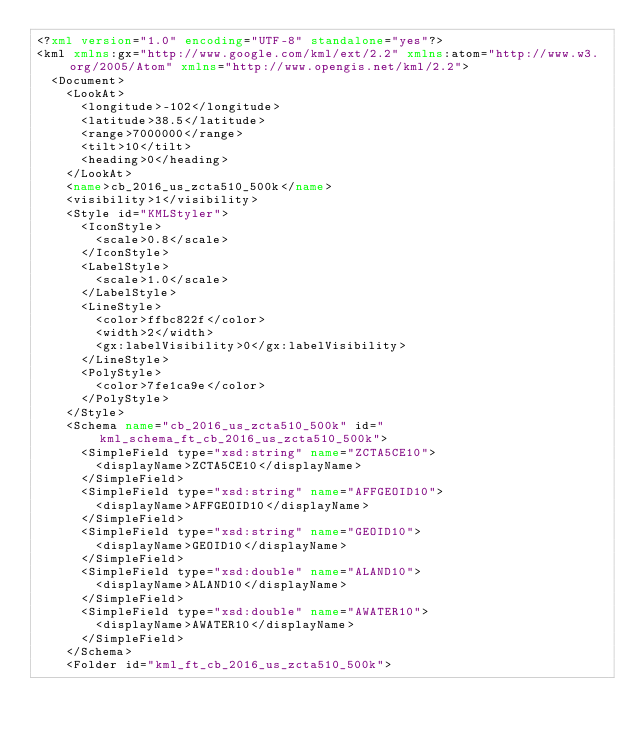<code> <loc_0><loc_0><loc_500><loc_500><_XML_><?xml version="1.0" encoding="UTF-8" standalone="yes"?>
<kml xmlns:gx="http://www.google.com/kml/ext/2.2" xmlns:atom="http://www.w3.org/2005/Atom" xmlns="http://www.opengis.net/kml/2.2">
  <Document>
    <LookAt>
      <longitude>-102</longitude>
      <latitude>38.5</latitude>
      <range>7000000</range>
      <tilt>10</tilt>
      <heading>0</heading>
    </LookAt>
    <name>cb_2016_us_zcta510_500k</name>
    <visibility>1</visibility>
    <Style id="KMLStyler">
      <IconStyle>
        <scale>0.8</scale>
      </IconStyle>
      <LabelStyle>
        <scale>1.0</scale>
      </LabelStyle>
      <LineStyle>
        <color>ffbc822f</color>
        <width>2</width>
        <gx:labelVisibility>0</gx:labelVisibility>
      </LineStyle>
      <PolyStyle>
        <color>7fe1ca9e</color>
      </PolyStyle>
    </Style>
    <Schema name="cb_2016_us_zcta510_500k" id="kml_schema_ft_cb_2016_us_zcta510_500k">
      <SimpleField type="xsd:string" name="ZCTA5CE10">
        <displayName>ZCTA5CE10</displayName>
      </SimpleField>
      <SimpleField type="xsd:string" name="AFFGEOID10">
        <displayName>AFFGEOID10</displayName>
      </SimpleField>
      <SimpleField type="xsd:string" name="GEOID10">
        <displayName>GEOID10</displayName>
      </SimpleField>
      <SimpleField type="xsd:double" name="ALAND10">
        <displayName>ALAND10</displayName>
      </SimpleField>
      <SimpleField type="xsd:double" name="AWATER10">
        <displayName>AWATER10</displayName>
      </SimpleField>
    </Schema>
    <Folder id="kml_ft_cb_2016_us_zcta510_500k"></code> 